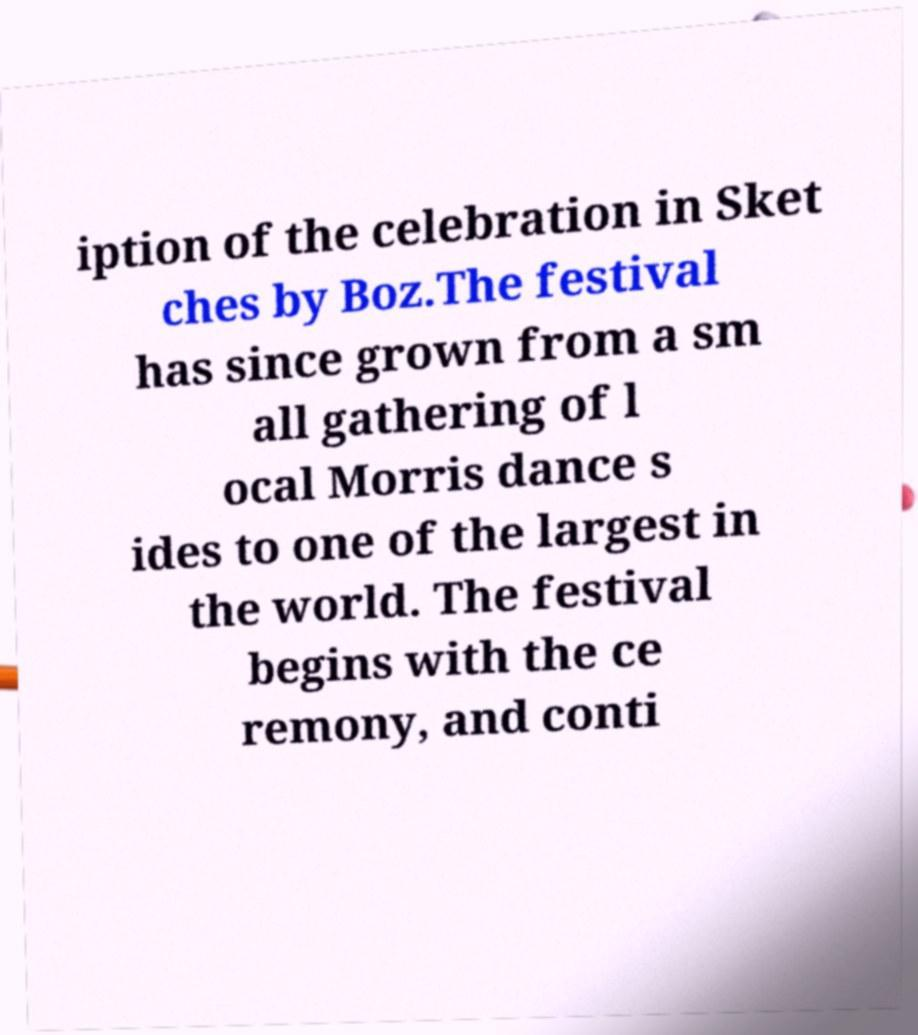Please read and relay the text visible in this image. What does it say? iption of the celebration in Sket ches by Boz.The festival has since grown from a sm all gathering of l ocal Morris dance s ides to one of the largest in the world. The festival begins with the ce remony, and conti 